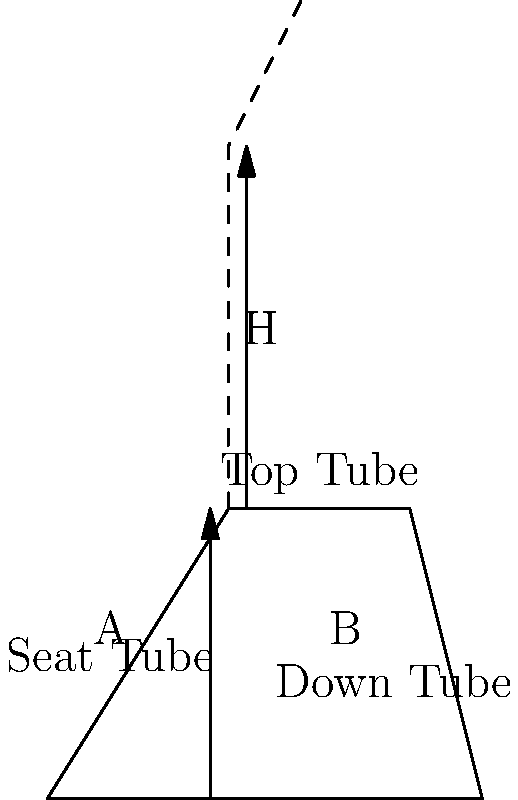As a professional BMX cyclist, you're helping design a new frame geometry optimization system. Given a rider's height (H) and inseam length (A), how would you calculate the optimal top tube length (B) using the formula $B = k \cdot \sqrt{H \cdot A}$, where $k$ is a constant? If $H = 180$ cm, $A = 85$ cm, and $k = 0.5$, what is the optimal top tube length? To calculate the optimal top tube length (B), we'll use the given formula and follow these steps:

1. Identify the given values:
   $H = 180$ cm (rider's height)
   $A = 85$ cm (inseam length)
   $k = 0.5$ (constant)

2. Substitute these values into the formula:
   $B = k \cdot \sqrt{H \cdot A}$

3. Calculate the product under the square root:
   $H \cdot A = 180 \text{ cm} \cdot 85 \text{ cm} = 15,300 \text{ cm}^2$

4. Calculate the square root:
   $\sqrt{15,300} \approx 123.69 \text{ cm}$

5. Multiply by the constant $k$:
   $B = 0.5 \cdot 123.69 \text{ cm} \approx 61.85 \text{ cm}$

6. Round to a practical measurement:
   $B \approx 62 \text{ cm}$

Therefore, the optimal top tube length for a rider with a height of 180 cm and an inseam length of 85 cm is approximately 62 cm.
Answer: 62 cm 